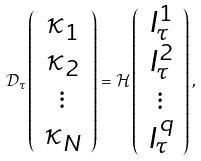<formula> <loc_0><loc_0><loc_500><loc_500>\mathcal { D } _ { \tau } \left ( \begin{array} { c } \kappa _ { 1 } \\ \kappa _ { 2 } \\ \vdots \\ \kappa _ { N } \end{array} \right ) = \mathcal { H } \left ( \begin{array} { c } I _ { \tau } ^ { 1 } \\ I _ { \tau } ^ { 2 } \\ \vdots \\ I _ { \tau } ^ { q } \end{array} \right ) ,</formula> 